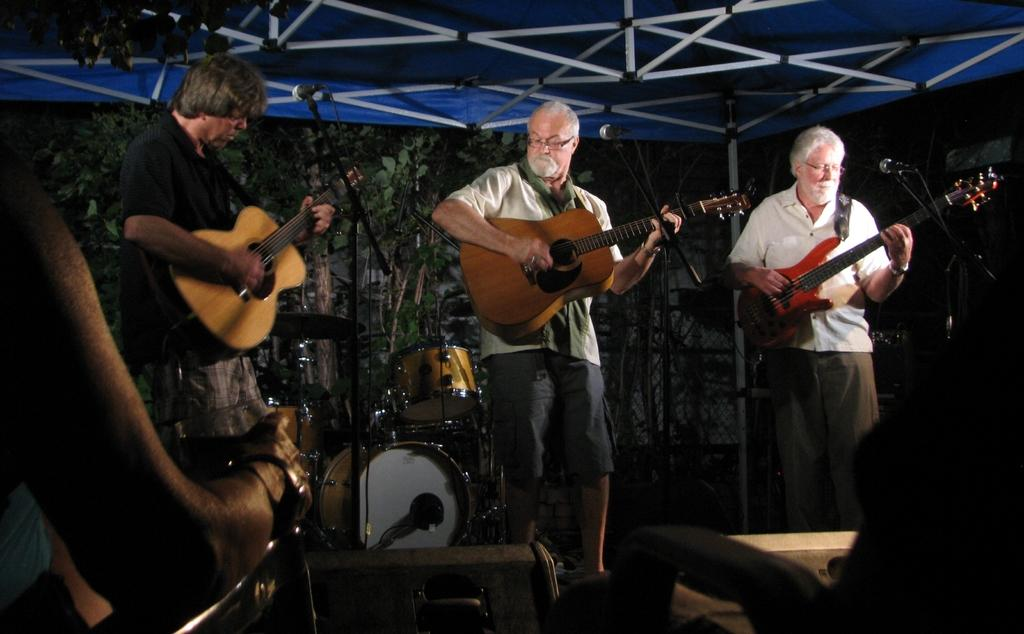How many men are in the image? There are three men in the image. What are the men doing in the image? The men are standing and playing guitar. What other musical instrument can be seen in the image? There are drums visible in the image. How are the drums positioned in the image? The drums are on the backs of the men. What device is present for amplifying sound in the image? There is a microphone in the image. Where is the microphone located in relation to the men? The microphone is in front of the men. Who is watching the men play music in the image? There is an audience in the image, and they are seated and watching the men. What type of stocking is the man wearing on his left foot in the image? There is no mention of stockings or any specific clothing items in the image. --- Facts: 1. There is a cat in the image. 2. The cat is sitting on a chair. 3. The chair is red. 4. There is a book on the chair. 5. The book is open. 6. The cat is looking at the book. Absurd Topics: bicycle, rain, mountain Conversation: What animal is in the image? There is a cat in the image. Where is the cat sitting in the image? The cat is sitting on a chair. What color is the chair? The chair is red. What object is on the chair with the cat? There is a book on the chair. Is the book open or closed in the image? The book is open in the image. What is the cat doing in relation to the book? The cat is looking at the book. Reasoning: Let's think step by step in order to produce the conversation. We start by identifying the main subject in the image, which is the cat. Then, we describe the cat's position and the color of the chair it is sitting on. Next, we mention the presence of the book and its open state. Finally, we describe the cat's interaction with the book. Each question is designed to elicit a specific detail about the image that is known from the provided facts. Absurd Question/Answer: Is the cat riding a bicycle in the rain on top of a mountain in the image? No, the image does not depict a cat riding a bicycle, nor does it show any rain or mountain. 